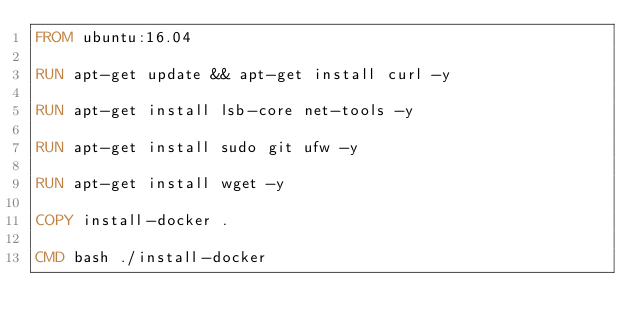<code> <loc_0><loc_0><loc_500><loc_500><_Dockerfile_>FROM ubuntu:16.04

RUN apt-get update && apt-get install curl -y

RUN apt-get install lsb-core net-tools -y

RUN apt-get install sudo git ufw -y

RUN apt-get install wget -y

COPY install-docker .

CMD bash ./install-docker
</code> 